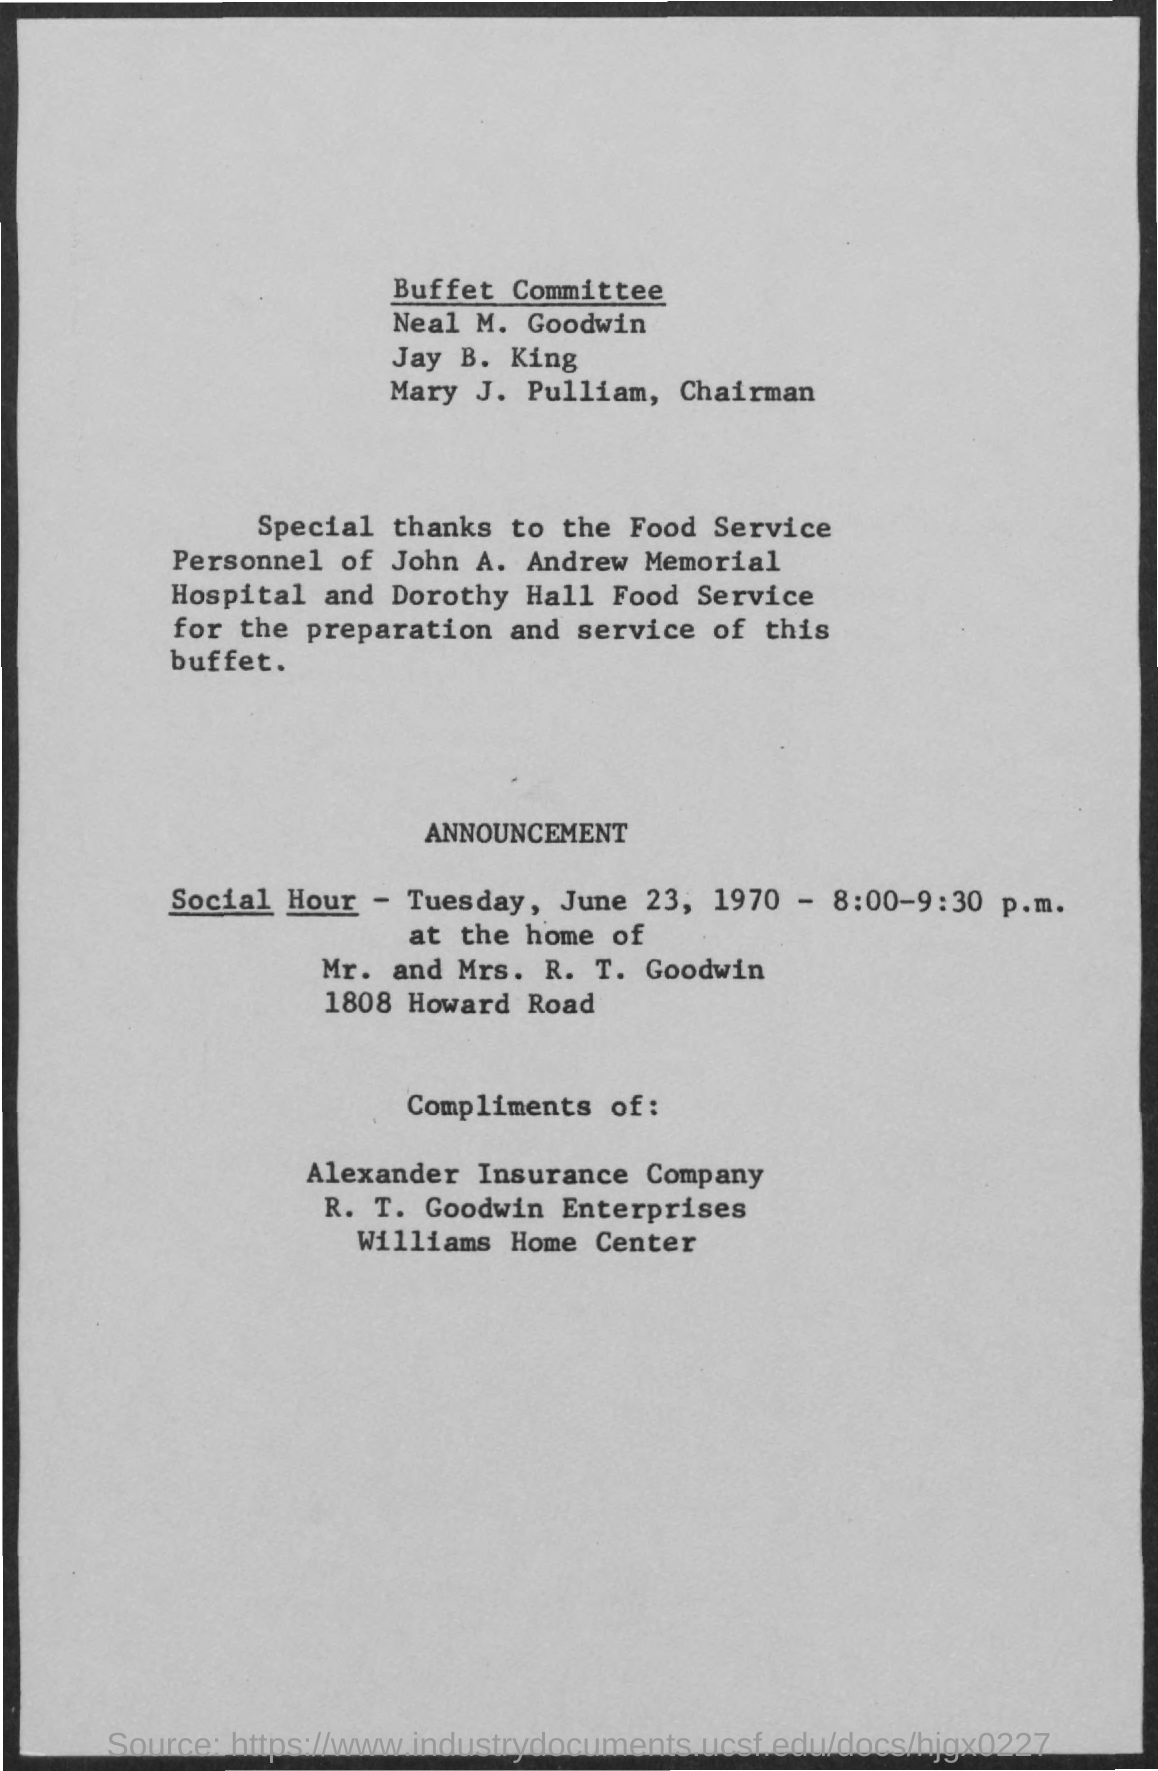Draw attention to some important aspects in this diagram. The announcement of "Social Hour" will take place between 8:00-9:30 P.M. The home of Mr. and Mrs. R. T. Goodwin is located at 1808 Howard Road. The chairman of the Buffett Committee is Mary J. Pulliam. Williams Home Center is the mention in the "Compliments of" section. I would like to express my sincere appreciation to Alexander Insurance Company for their exceptional service and support. 